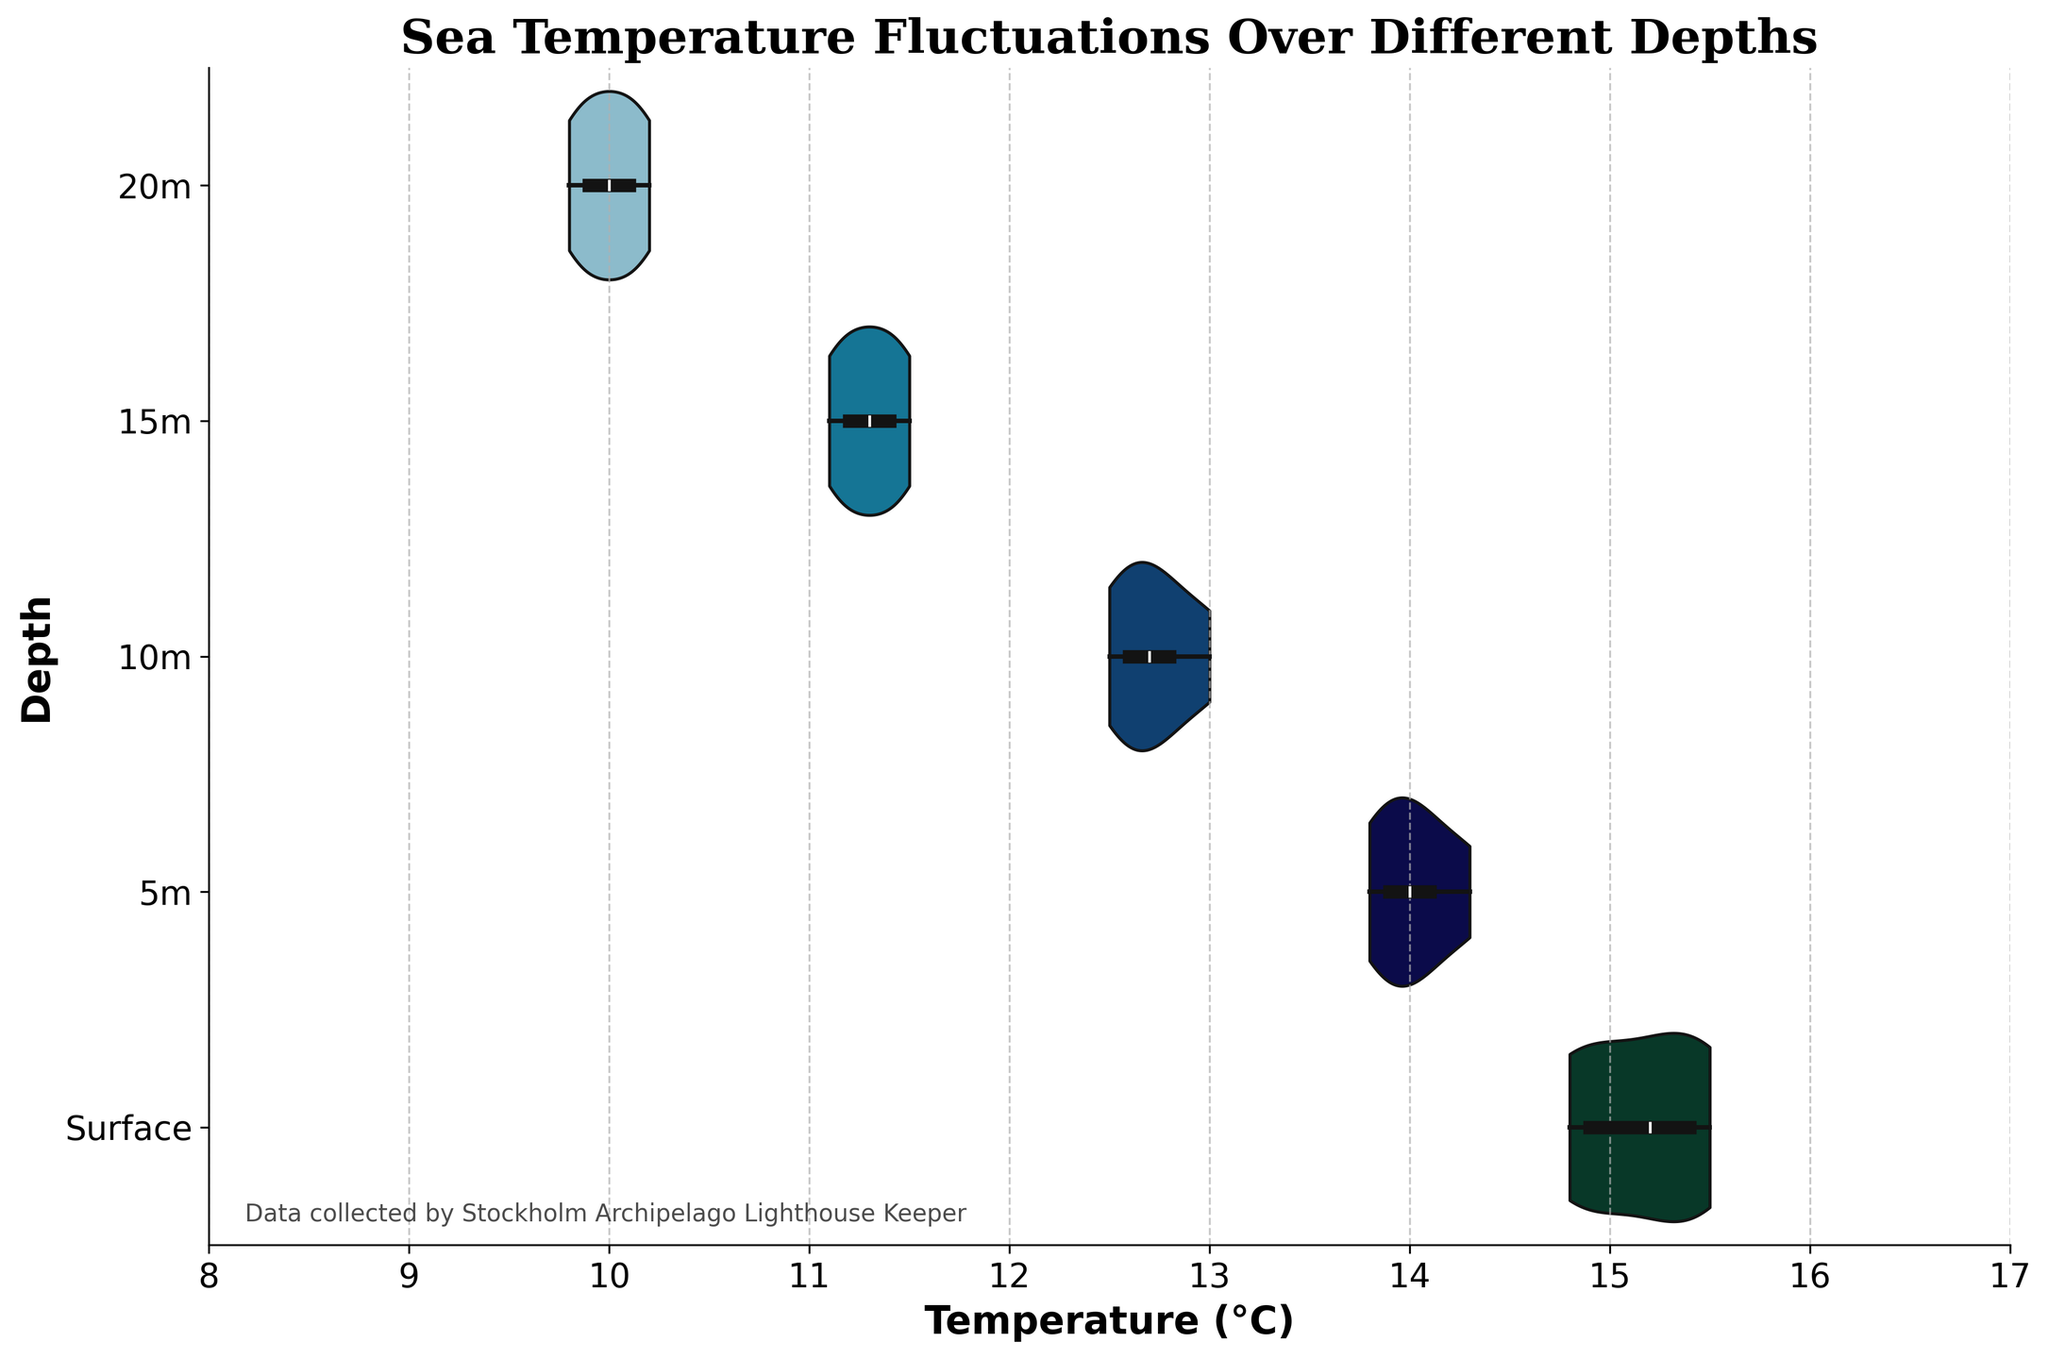What is the title of the figure? The title is displayed at the top of the figure in large, bold text. It provides an overview of what the chart is representing.
Answer: Sea Temperature Fluctuations Over Different Depths What is the temperature range shown on the x-axis? The x-axis represents the temperature in degrees Celsius, and the range is clearly marked at the bottom of the chart.
Answer: 8 to 17°C Which depth has the highest median temperature? The median temperature is shown as a central line in each violin plot. By comparing these lines across depths, we can determine the highest median.
Answer: Surface How does the temperature distribution at the surface compare to the temperature distribution at 20m? The shape of the violin plots can be compared to see how temperatures are spread out at different depths. The surface distribution is wider, indicating more variation, while the 20m distribution is more compact.
Answer: Surface has more variation; 20m is more compact What detail is indicated by the text at the bottom left of the figure? There is a small text annotation in the bottom left corner of the figure that provides information about the data source.
Answer: Data collected by Stockholm Archipelago Lighthouse Keeper Which depth shows the narrowest range in temperature fluctuations? The width of each violin plot shows the spread of the data. The narrowest part will have the least range in temperature variations.
Answer: 20m How many distinct depths are represented in the chart? The y-axis lists all the depths that are represented by different violin plots. By counting these labels, we can determine the number of distinct depths.
Answer: 5 What is the interquartile range (IQR) of temperatures at 10m depth? The IQR can be approximated by looking at the box within the violin plot, which represents the middle 50% of the data points (from the first quartile to the third quartile).
Answer: Approximately 12.6 to 12.8°C Which depth shows the lowest maximum temperature? The maximum temperature can be identified by the topmost point of each violin plot. By comparing these across depths, we find the lowest one.
Answer: 20m Is there any trend observed in temperature changes with increasing depth? By observing the shifts in the median lines and the overall shape of the violin plots from surface to 20m, a trend can be identified.
Answer: Temperature decreases with depth 